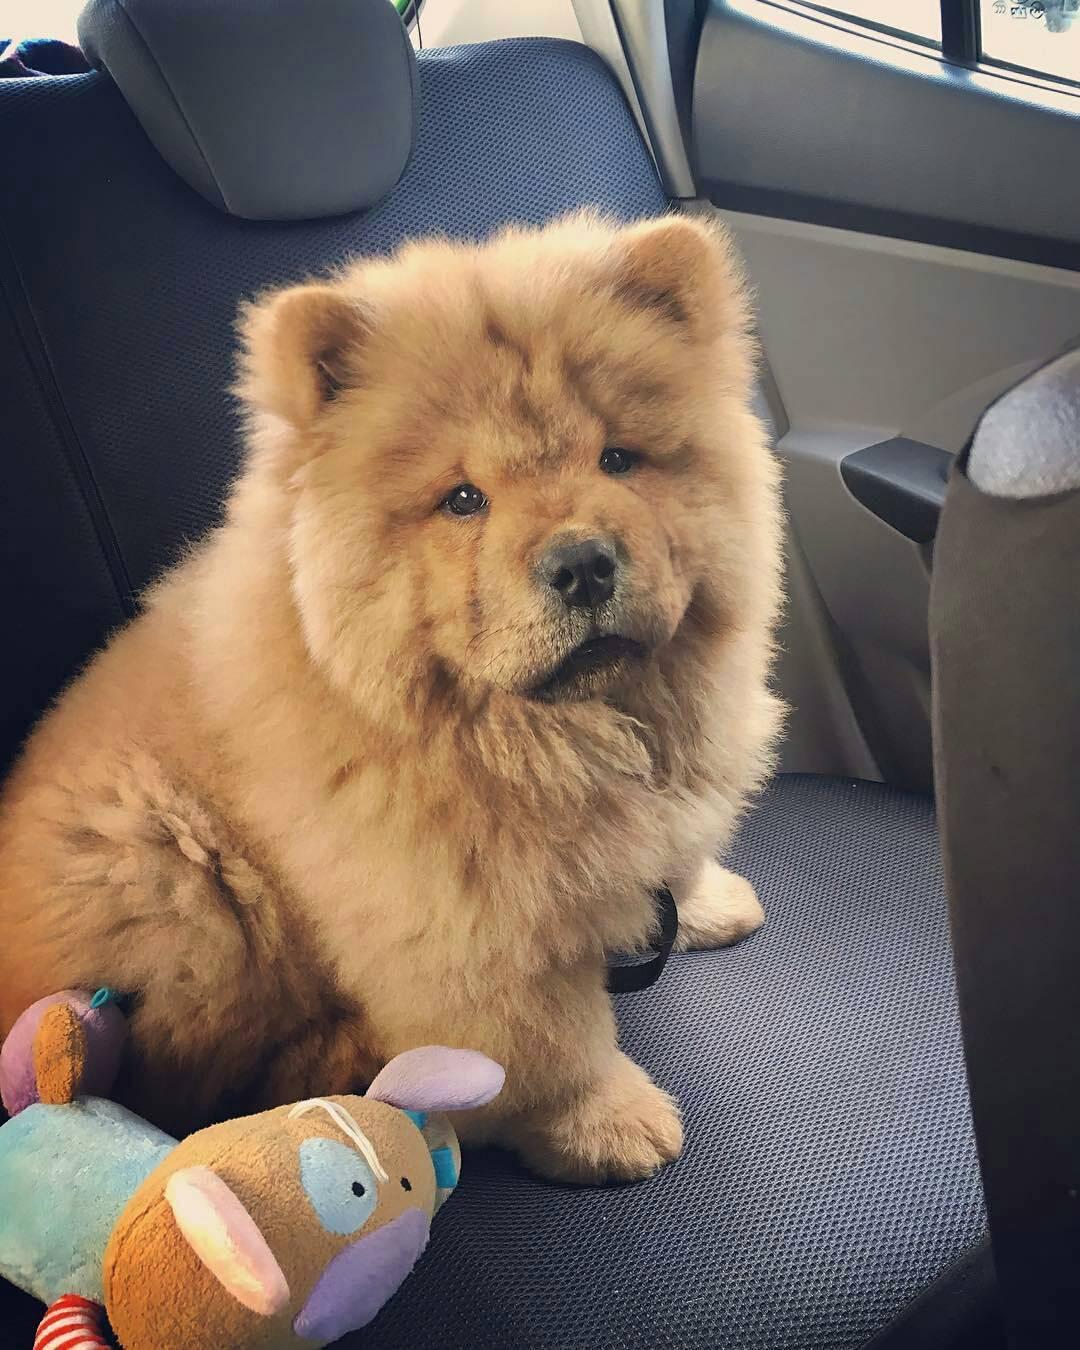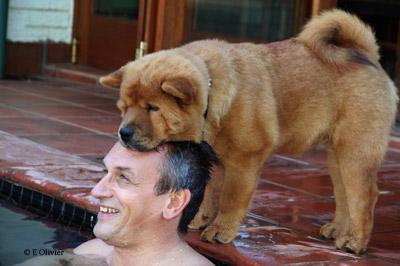The first image is the image on the left, the second image is the image on the right. Given the left and right images, does the statement "Two dogs are sitting together in one of the images." hold true? Answer yes or no. No. The first image is the image on the left, the second image is the image on the right. Considering the images on both sides, is "In one image of a chow dog, a human leg in jeans is visible." valid? Answer yes or no. No. 